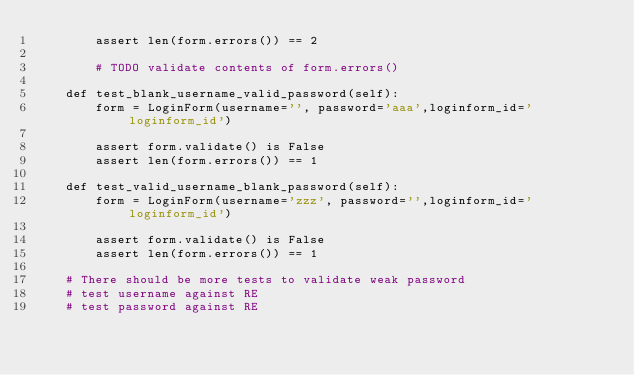Convert code to text. <code><loc_0><loc_0><loc_500><loc_500><_Python_>        assert len(form.errors()) == 2

        # TODO validate contents of form.errors()

    def test_blank_username_valid_password(self):
        form = LoginForm(username='', password='aaa',loginform_id='loginform_id')
        
        assert form.validate() is False
        assert len(form.errors()) == 1

    def test_valid_username_blank_password(self):
        form = LoginForm(username='zzz', password='',loginform_id='loginform_id')
        
        assert form.validate() is False
        assert len(form.errors()) == 1

    # There should be more tests to validate weak password
    # test username against RE
    # test password against RE
</code> 